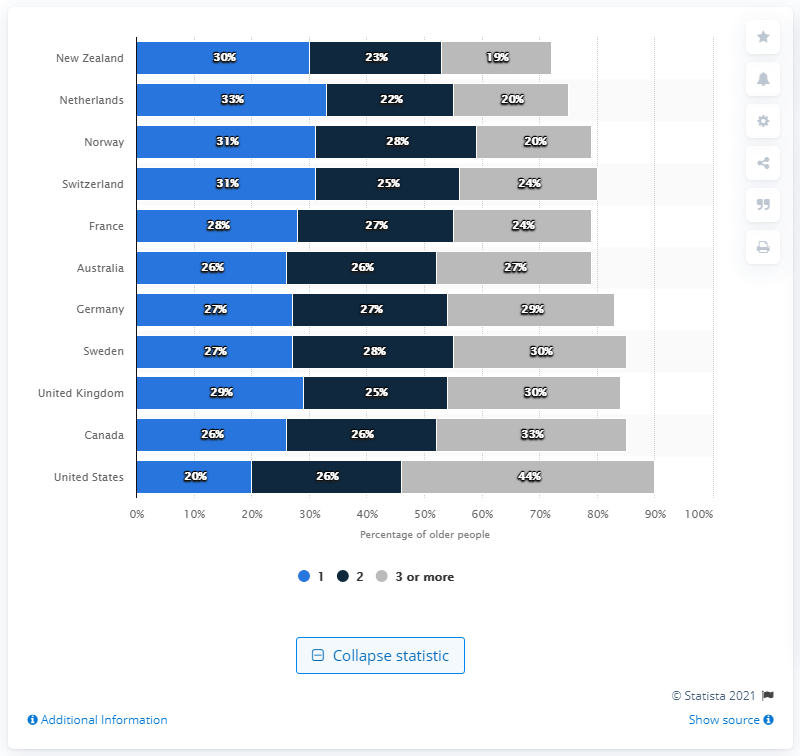Specify some key components in this picture. The United States has a greater disparity between two or more chronic conditions compared to Canada. The color bar with the largest percent value is gray. 